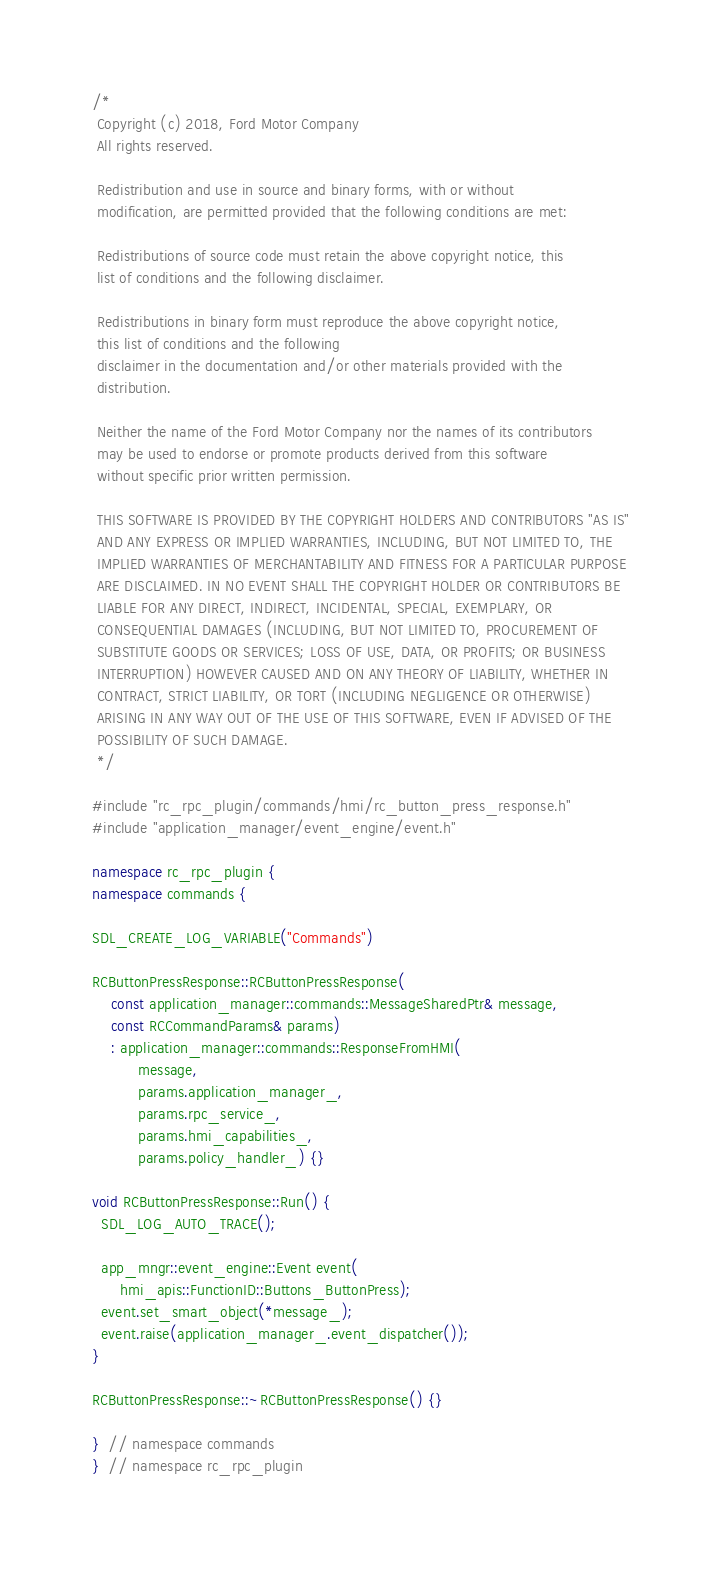<code> <loc_0><loc_0><loc_500><loc_500><_C++_>/*
 Copyright (c) 2018, Ford Motor Company
 All rights reserved.

 Redistribution and use in source and binary forms, with or without
 modification, are permitted provided that the following conditions are met:

 Redistributions of source code must retain the above copyright notice, this
 list of conditions and the following disclaimer.

 Redistributions in binary form must reproduce the above copyright notice,
 this list of conditions and the following
 disclaimer in the documentation and/or other materials provided with the
 distribution.

 Neither the name of the Ford Motor Company nor the names of its contributors
 may be used to endorse or promote products derived from this software
 without specific prior written permission.

 THIS SOFTWARE IS PROVIDED BY THE COPYRIGHT HOLDERS AND CONTRIBUTORS "AS IS"
 AND ANY EXPRESS OR IMPLIED WARRANTIES, INCLUDING, BUT NOT LIMITED TO, THE
 IMPLIED WARRANTIES OF MERCHANTABILITY AND FITNESS FOR A PARTICULAR PURPOSE
 ARE DISCLAIMED. IN NO EVENT SHALL THE COPYRIGHT HOLDER OR CONTRIBUTORS BE
 LIABLE FOR ANY DIRECT, INDIRECT, INCIDENTAL, SPECIAL, EXEMPLARY, OR
 CONSEQUENTIAL DAMAGES (INCLUDING, BUT NOT LIMITED TO, PROCUREMENT OF
 SUBSTITUTE GOODS OR SERVICES; LOSS OF USE, DATA, OR PROFITS; OR BUSINESS
 INTERRUPTION) HOWEVER CAUSED AND ON ANY THEORY OF LIABILITY, WHETHER IN
 CONTRACT, STRICT LIABILITY, OR TORT (INCLUDING NEGLIGENCE OR OTHERWISE)
 ARISING IN ANY WAY OUT OF THE USE OF THIS SOFTWARE, EVEN IF ADVISED OF THE
 POSSIBILITY OF SUCH DAMAGE.
 */

#include "rc_rpc_plugin/commands/hmi/rc_button_press_response.h"
#include "application_manager/event_engine/event.h"

namespace rc_rpc_plugin {
namespace commands {

SDL_CREATE_LOG_VARIABLE("Commands")

RCButtonPressResponse::RCButtonPressResponse(
    const application_manager::commands::MessageSharedPtr& message,
    const RCCommandParams& params)
    : application_manager::commands::ResponseFromHMI(
          message,
          params.application_manager_,
          params.rpc_service_,
          params.hmi_capabilities_,
          params.policy_handler_) {}

void RCButtonPressResponse::Run() {
  SDL_LOG_AUTO_TRACE();

  app_mngr::event_engine::Event event(
      hmi_apis::FunctionID::Buttons_ButtonPress);
  event.set_smart_object(*message_);
  event.raise(application_manager_.event_dispatcher());
}

RCButtonPressResponse::~RCButtonPressResponse() {}

}  // namespace commands
}  // namespace rc_rpc_plugin
</code> 